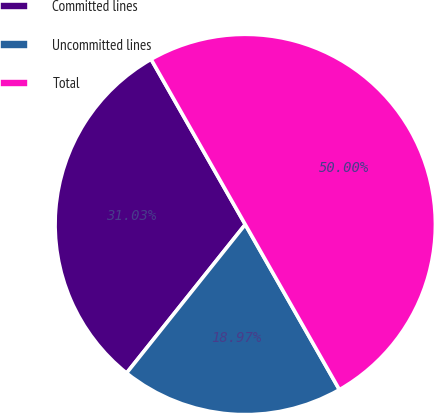Convert chart. <chart><loc_0><loc_0><loc_500><loc_500><pie_chart><fcel>Committed lines<fcel>Uncommitted lines<fcel>Total<nl><fcel>31.03%<fcel>18.97%<fcel>50.0%<nl></chart> 